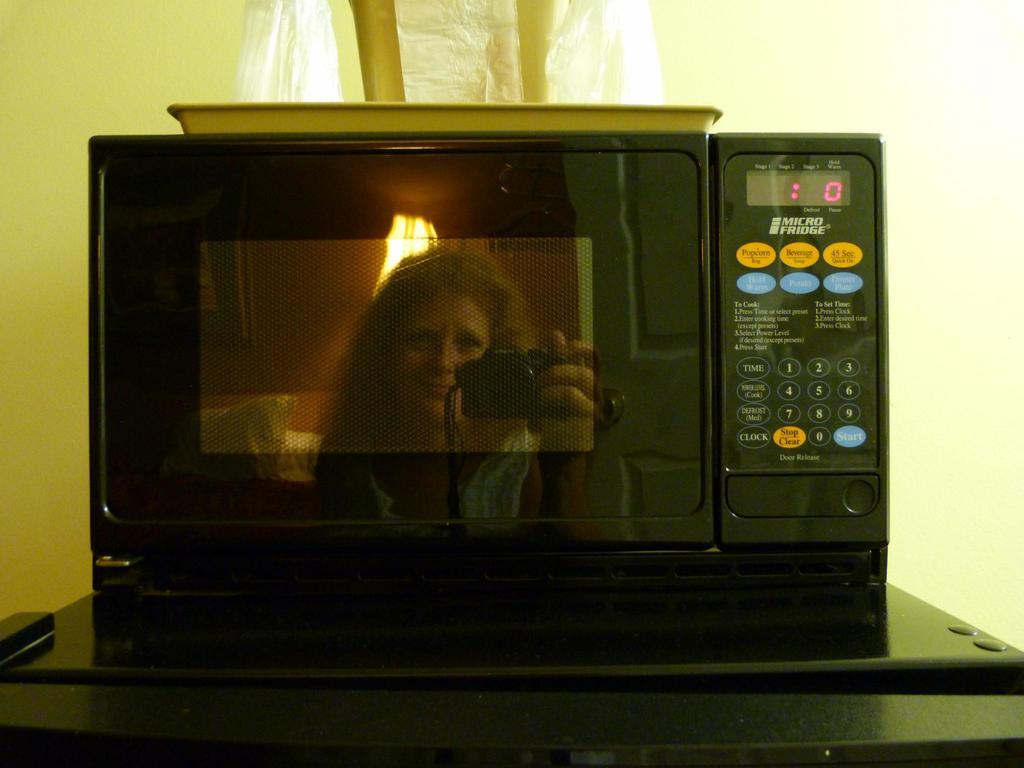<image>
Share a concise interpretation of the image provided. A woman is taking a photograph in front of a Micro Fridge microwave. 